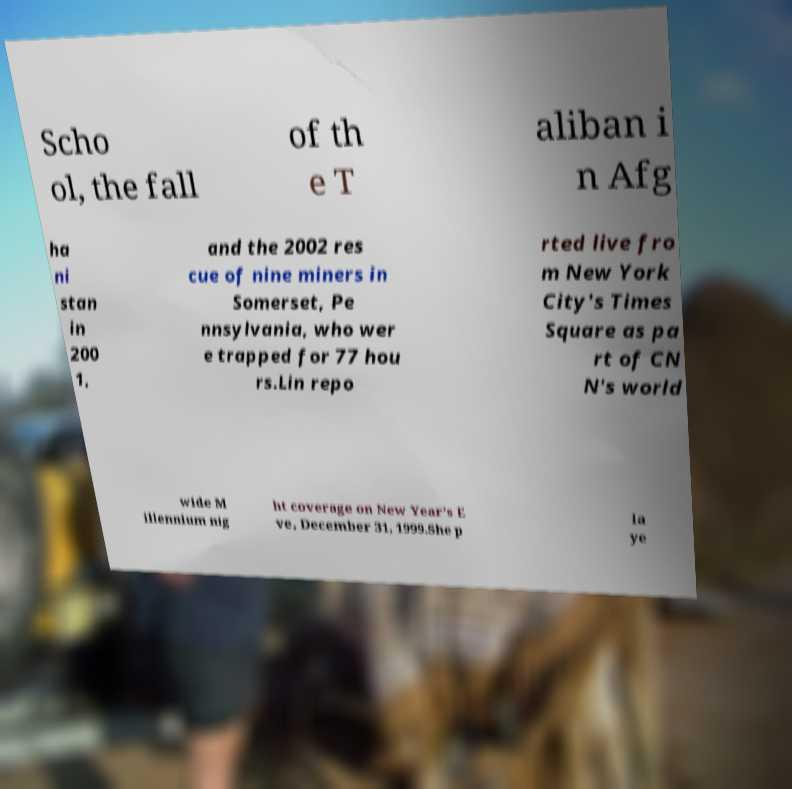What messages or text are displayed in this image? I need them in a readable, typed format. Scho ol, the fall of th e T aliban i n Afg ha ni stan in 200 1, and the 2002 res cue of nine miners in Somerset, Pe nnsylvania, who wer e trapped for 77 hou rs.Lin repo rted live fro m New York City's Times Square as pa rt of CN N's world wide M illennium nig ht coverage on New Year's E ve, December 31, 1999.She p la ye 